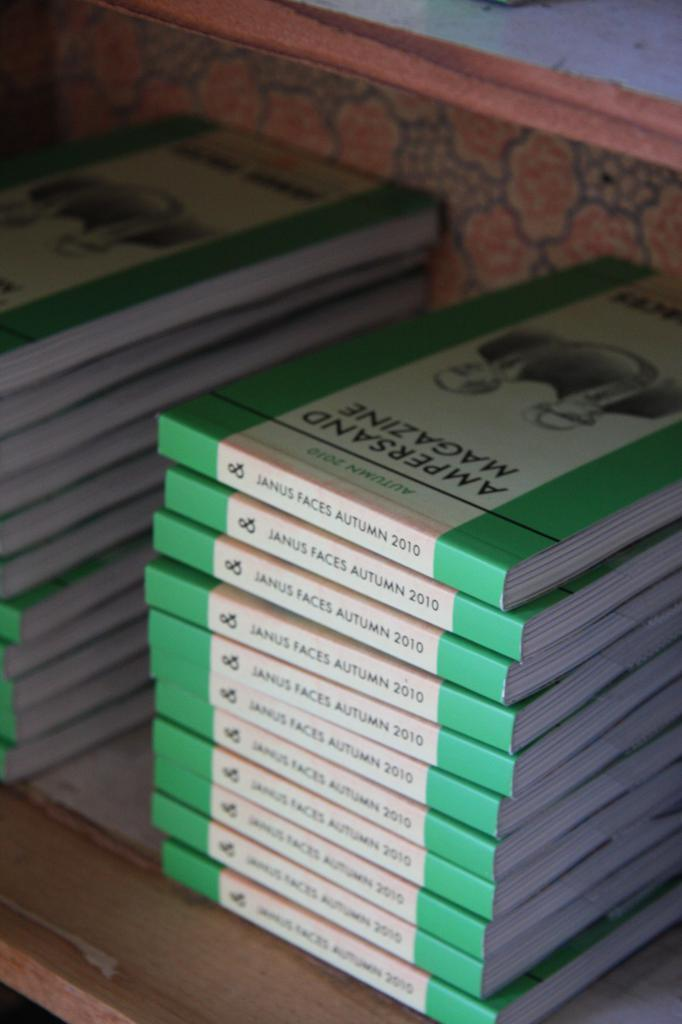<image>
Share a concise interpretation of the image provided. A stack of Ampersand magazines sit on a shelf. 